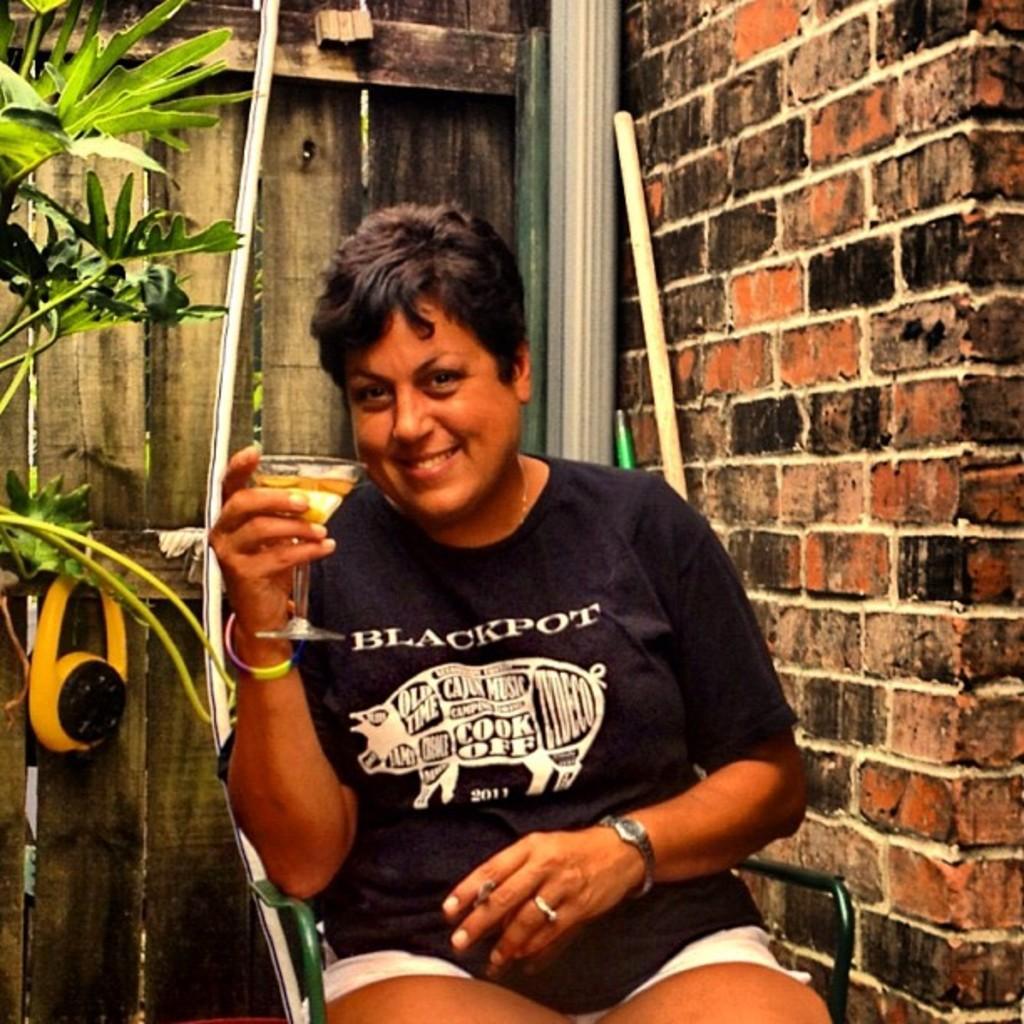Please provide a concise description of this image. In this image we can see this person wearing black T-shirt is holding a glass with drink and cigarette and sitting on the chair and is smiling. In the background, we can see wooden wall, we can see plants, pipes and the brick wall. 